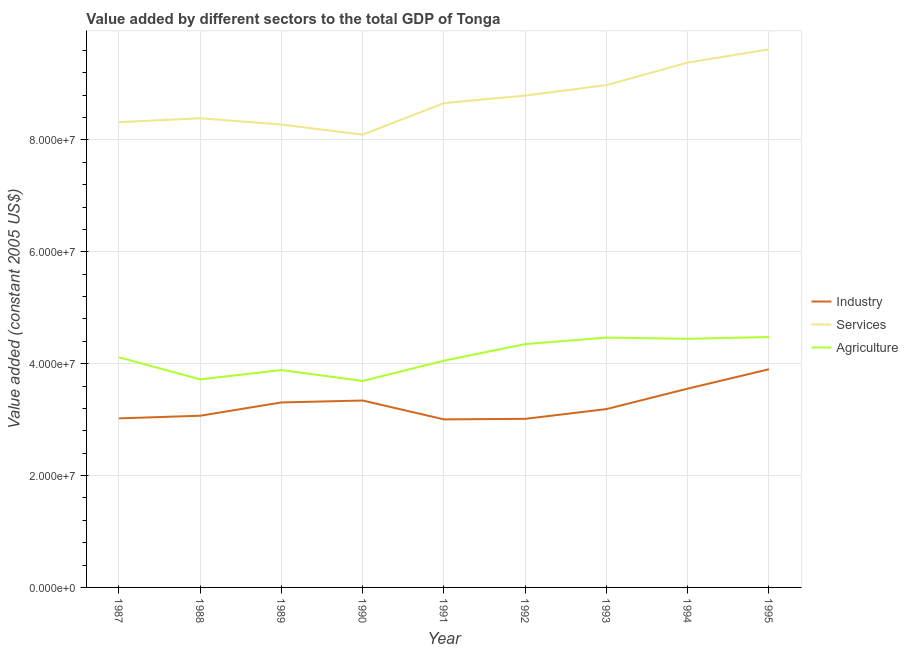What is the value added by industrial sector in 1991?
Offer a very short reply. 3.00e+07. Across all years, what is the maximum value added by agricultural sector?
Provide a short and direct response. 4.48e+07. Across all years, what is the minimum value added by services?
Keep it short and to the point. 8.09e+07. In which year was the value added by agricultural sector minimum?
Your response must be concise. 1990. What is the total value added by services in the graph?
Your answer should be compact. 7.85e+08. What is the difference between the value added by industrial sector in 1989 and that in 1991?
Ensure brevity in your answer.  3.03e+06. What is the difference between the value added by services in 1988 and the value added by agricultural sector in 1993?
Give a very brief answer. 3.92e+07. What is the average value added by agricultural sector per year?
Make the answer very short. 4.13e+07. In the year 1994, what is the difference between the value added by agricultural sector and value added by industrial sector?
Your answer should be very brief. 8.91e+06. In how many years, is the value added by agricultural sector greater than 80000000 US$?
Provide a short and direct response. 0. What is the ratio of the value added by services in 1988 to that in 1995?
Give a very brief answer. 0.87. Is the value added by industrial sector in 1990 less than that in 1992?
Your answer should be very brief. No. What is the difference between the highest and the second highest value added by agricultural sector?
Your answer should be compact. 1.02e+05. What is the difference between the highest and the lowest value added by services?
Ensure brevity in your answer.  1.53e+07. Is it the case that in every year, the sum of the value added by industrial sector and value added by services is greater than the value added by agricultural sector?
Provide a succinct answer. Yes. Does the value added by industrial sector monotonically increase over the years?
Give a very brief answer. No. Is the value added by services strictly less than the value added by agricultural sector over the years?
Keep it short and to the point. No. How many lines are there?
Your answer should be very brief. 3. How many years are there in the graph?
Provide a short and direct response. 9. Are the values on the major ticks of Y-axis written in scientific E-notation?
Give a very brief answer. Yes. How many legend labels are there?
Make the answer very short. 3. How are the legend labels stacked?
Keep it short and to the point. Vertical. What is the title of the graph?
Your response must be concise. Value added by different sectors to the total GDP of Tonga. What is the label or title of the Y-axis?
Offer a very short reply. Value added (constant 2005 US$). What is the Value added (constant 2005 US$) in Industry in 1987?
Your answer should be very brief. 3.02e+07. What is the Value added (constant 2005 US$) of Services in 1987?
Offer a very short reply. 8.32e+07. What is the Value added (constant 2005 US$) in Agriculture in 1987?
Give a very brief answer. 4.11e+07. What is the Value added (constant 2005 US$) in Industry in 1988?
Keep it short and to the point. 3.07e+07. What is the Value added (constant 2005 US$) of Services in 1988?
Your response must be concise. 8.39e+07. What is the Value added (constant 2005 US$) in Agriculture in 1988?
Provide a short and direct response. 3.72e+07. What is the Value added (constant 2005 US$) in Industry in 1989?
Offer a very short reply. 3.31e+07. What is the Value added (constant 2005 US$) of Services in 1989?
Make the answer very short. 8.28e+07. What is the Value added (constant 2005 US$) in Agriculture in 1989?
Offer a very short reply. 3.89e+07. What is the Value added (constant 2005 US$) of Industry in 1990?
Provide a short and direct response. 3.34e+07. What is the Value added (constant 2005 US$) in Services in 1990?
Make the answer very short. 8.09e+07. What is the Value added (constant 2005 US$) in Agriculture in 1990?
Your response must be concise. 3.69e+07. What is the Value added (constant 2005 US$) of Industry in 1991?
Provide a short and direct response. 3.00e+07. What is the Value added (constant 2005 US$) in Services in 1991?
Your answer should be compact. 8.66e+07. What is the Value added (constant 2005 US$) in Agriculture in 1991?
Offer a very short reply. 4.05e+07. What is the Value added (constant 2005 US$) in Industry in 1992?
Your response must be concise. 3.01e+07. What is the Value added (constant 2005 US$) in Services in 1992?
Offer a very short reply. 8.79e+07. What is the Value added (constant 2005 US$) in Agriculture in 1992?
Offer a very short reply. 4.35e+07. What is the Value added (constant 2005 US$) of Industry in 1993?
Your answer should be very brief. 3.19e+07. What is the Value added (constant 2005 US$) in Services in 1993?
Your response must be concise. 8.98e+07. What is the Value added (constant 2005 US$) in Agriculture in 1993?
Offer a very short reply. 4.47e+07. What is the Value added (constant 2005 US$) of Industry in 1994?
Ensure brevity in your answer.  3.55e+07. What is the Value added (constant 2005 US$) in Services in 1994?
Give a very brief answer. 9.38e+07. What is the Value added (constant 2005 US$) in Agriculture in 1994?
Keep it short and to the point. 4.44e+07. What is the Value added (constant 2005 US$) in Industry in 1995?
Keep it short and to the point. 3.90e+07. What is the Value added (constant 2005 US$) of Services in 1995?
Ensure brevity in your answer.  9.62e+07. What is the Value added (constant 2005 US$) in Agriculture in 1995?
Give a very brief answer. 4.48e+07. Across all years, what is the maximum Value added (constant 2005 US$) in Industry?
Your answer should be very brief. 3.90e+07. Across all years, what is the maximum Value added (constant 2005 US$) in Services?
Offer a very short reply. 9.62e+07. Across all years, what is the maximum Value added (constant 2005 US$) of Agriculture?
Make the answer very short. 4.48e+07. Across all years, what is the minimum Value added (constant 2005 US$) of Industry?
Keep it short and to the point. 3.00e+07. Across all years, what is the minimum Value added (constant 2005 US$) in Services?
Provide a short and direct response. 8.09e+07. Across all years, what is the minimum Value added (constant 2005 US$) of Agriculture?
Give a very brief answer. 3.69e+07. What is the total Value added (constant 2005 US$) in Industry in the graph?
Your answer should be very brief. 2.94e+08. What is the total Value added (constant 2005 US$) of Services in the graph?
Your response must be concise. 7.85e+08. What is the total Value added (constant 2005 US$) of Agriculture in the graph?
Offer a terse response. 3.72e+08. What is the difference between the Value added (constant 2005 US$) of Industry in 1987 and that in 1988?
Offer a very short reply. -4.72e+05. What is the difference between the Value added (constant 2005 US$) of Services in 1987 and that in 1988?
Offer a terse response. -6.96e+05. What is the difference between the Value added (constant 2005 US$) of Agriculture in 1987 and that in 1988?
Offer a very short reply. 3.95e+06. What is the difference between the Value added (constant 2005 US$) of Industry in 1987 and that in 1989?
Offer a terse response. -2.85e+06. What is the difference between the Value added (constant 2005 US$) in Services in 1987 and that in 1989?
Offer a very short reply. 4.27e+05. What is the difference between the Value added (constant 2005 US$) of Agriculture in 1987 and that in 1989?
Make the answer very short. 2.28e+06. What is the difference between the Value added (constant 2005 US$) of Industry in 1987 and that in 1990?
Your answer should be compact. -3.19e+06. What is the difference between the Value added (constant 2005 US$) in Services in 1987 and that in 1990?
Provide a succinct answer. 2.23e+06. What is the difference between the Value added (constant 2005 US$) of Agriculture in 1987 and that in 1990?
Your response must be concise. 4.24e+06. What is the difference between the Value added (constant 2005 US$) in Industry in 1987 and that in 1991?
Ensure brevity in your answer.  1.77e+05. What is the difference between the Value added (constant 2005 US$) in Services in 1987 and that in 1991?
Make the answer very short. -3.40e+06. What is the difference between the Value added (constant 2005 US$) in Agriculture in 1987 and that in 1991?
Offer a very short reply. 6.11e+05. What is the difference between the Value added (constant 2005 US$) of Industry in 1987 and that in 1992?
Your response must be concise. 8.38e+04. What is the difference between the Value added (constant 2005 US$) in Services in 1987 and that in 1992?
Offer a very short reply. -4.75e+06. What is the difference between the Value added (constant 2005 US$) of Agriculture in 1987 and that in 1992?
Provide a short and direct response. -2.36e+06. What is the difference between the Value added (constant 2005 US$) in Industry in 1987 and that in 1993?
Your response must be concise. -1.66e+06. What is the difference between the Value added (constant 2005 US$) of Services in 1987 and that in 1993?
Your answer should be compact. -6.63e+06. What is the difference between the Value added (constant 2005 US$) in Agriculture in 1987 and that in 1993?
Offer a terse response. -3.52e+06. What is the difference between the Value added (constant 2005 US$) of Industry in 1987 and that in 1994?
Your answer should be compact. -5.32e+06. What is the difference between the Value added (constant 2005 US$) of Services in 1987 and that in 1994?
Keep it short and to the point. -1.06e+07. What is the difference between the Value added (constant 2005 US$) in Agriculture in 1987 and that in 1994?
Make the answer very short. -3.30e+06. What is the difference between the Value added (constant 2005 US$) of Industry in 1987 and that in 1995?
Offer a very short reply. -8.78e+06. What is the difference between the Value added (constant 2005 US$) in Services in 1987 and that in 1995?
Make the answer very short. -1.30e+07. What is the difference between the Value added (constant 2005 US$) in Agriculture in 1987 and that in 1995?
Your answer should be compact. -3.62e+06. What is the difference between the Value added (constant 2005 US$) of Industry in 1988 and that in 1989?
Provide a succinct answer. -2.38e+06. What is the difference between the Value added (constant 2005 US$) of Services in 1988 and that in 1989?
Give a very brief answer. 1.12e+06. What is the difference between the Value added (constant 2005 US$) in Agriculture in 1988 and that in 1989?
Ensure brevity in your answer.  -1.67e+06. What is the difference between the Value added (constant 2005 US$) in Industry in 1988 and that in 1990?
Make the answer very short. -2.72e+06. What is the difference between the Value added (constant 2005 US$) of Services in 1988 and that in 1990?
Your answer should be very brief. 2.93e+06. What is the difference between the Value added (constant 2005 US$) in Agriculture in 1988 and that in 1990?
Make the answer very short. 2.86e+05. What is the difference between the Value added (constant 2005 US$) in Industry in 1988 and that in 1991?
Provide a succinct answer. 6.49e+05. What is the difference between the Value added (constant 2005 US$) of Services in 1988 and that in 1991?
Keep it short and to the point. -2.71e+06. What is the difference between the Value added (constant 2005 US$) in Agriculture in 1988 and that in 1991?
Ensure brevity in your answer.  -3.34e+06. What is the difference between the Value added (constant 2005 US$) in Industry in 1988 and that in 1992?
Give a very brief answer. 5.56e+05. What is the difference between the Value added (constant 2005 US$) of Services in 1988 and that in 1992?
Ensure brevity in your answer.  -4.06e+06. What is the difference between the Value added (constant 2005 US$) of Agriculture in 1988 and that in 1992?
Provide a short and direct response. -6.31e+06. What is the difference between the Value added (constant 2005 US$) in Industry in 1988 and that in 1993?
Ensure brevity in your answer.  -1.19e+06. What is the difference between the Value added (constant 2005 US$) of Services in 1988 and that in 1993?
Offer a terse response. -5.93e+06. What is the difference between the Value added (constant 2005 US$) of Agriculture in 1988 and that in 1993?
Provide a succinct answer. -7.47e+06. What is the difference between the Value added (constant 2005 US$) of Industry in 1988 and that in 1994?
Give a very brief answer. -4.85e+06. What is the difference between the Value added (constant 2005 US$) in Services in 1988 and that in 1994?
Give a very brief answer. -9.95e+06. What is the difference between the Value added (constant 2005 US$) in Agriculture in 1988 and that in 1994?
Your answer should be compact. -7.25e+06. What is the difference between the Value added (constant 2005 US$) of Industry in 1988 and that in 1995?
Ensure brevity in your answer.  -8.31e+06. What is the difference between the Value added (constant 2005 US$) of Services in 1988 and that in 1995?
Provide a short and direct response. -1.23e+07. What is the difference between the Value added (constant 2005 US$) of Agriculture in 1988 and that in 1995?
Your answer should be very brief. -7.57e+06. What is the difference between the Value added (constant 2005 US$) of Industry in 1989 and that in 1990?
Ensure brevity in your answer.  -3.42e+05. What is the difference between the Value added (constant 2005 US$) in Services in 1989 and that in 1990?
Your answer should be very brief. 1.81e+06. What is the difference between the Value added (constant 2005 US$) in Agriculture in 1989 and that in 1990?
Make the answer very short. 1.96e+06. What is the difference between the Value added (constant 2005 US$) of Industry in 1989 and that in 1991?
Offer a terse response. 3.03e+06. What is the difference between the Value added (constant 2005 US$) of Services in 1989 and that in 1991?
Ensure brevity in your answer.  -3.83e+06. What is the difference between the Value added (constant 2005 US$) in Agriculture in 1989 and that in 1991?
Make the answer very short. -1.67e+06. What is the difference between the Value added (constant 2005 US$) in Industry in 1989 and that in 1992?
Your answer should be very brief. 2.93e+06. What is the difference between the Value added (constant 2005 US$) of Services in 1989 and that in 1992?
Offer a terse response. -5.18e+06. What is the difference between the Value added (constant 2005 US$) in Agriculture in 1989 and that in 1992?
Offer a very short reply. -4.64e+06. What is the difference between the Value added (constant 2005 US$) in Industry in 1989 and that in 1993?
Provide a short and direct response. 1.19e+06. What is the difference between the Value added (constant 2005 US$) of Services in 1989 and that in 1993?
Offer a terse response. -7.05e+06. What is the difference between the Value added (constant 2005 US$) in Agriculture in 1989 and that in 1993?
Your answer should be very brief. -5.80e+06. What is the difference between the Value added (constant 2005 US$) of Industry in 1989 and that in 1994?
Offer a terse response. -2.47e+06. What is the difference between the Value added (constant 2005 US$) of Services in 1989 and that in 1994?
Provide a short and direct response. -1.11e+07. What is the difference between the Value added (constant 2005 US$) in Agriculture in 1989 and that in 1994?
Ensure brevity in your answer.  -5.58e+06. What is the difference between the Value added (constant 2005 US$) in Industry in 1989 and that in 1995?
Make the answer very short. -5.93e+06. What is the difference between the Value added (constant 2005 US$) in Services in 1989 and that in 1995?
Ensure brevity in your answer.  -1.34e+07. What is the difference between the Value added (constant 2005 US$) of Agriculture in 1989 and that in 1995?
Your answer should be very brief. -5.90e+06. What is the difference between the Value added (constant 2005 US$) in Industry in 1990 and that in 1991?
Ensure brevity in your answer.  3.37e+06. What is the difference between the Value added (constant 2005 US$) in Services in 1990 and that in 1991?
Offer a terse response. -5.64e+06. What is the difference between the Value added (constant 2005 US$) in Agriculture in 1990 and that in 1991?
Provide a succinct answer. -3.63e+06. What is the difference between the Value added (constant 2005 US$) of Industry in 1990 and that in 1992?
Keep it short and to the point. 3.28e+06. What is the difference between the Value added (constant 2005 US$) in Services in 1990 and that in 1992?
Offer a very short reply. -6.99e+06. What is the difference between the Value added (constant 2005 US$) of Agriculture in 1990 and that in 1992?
Give a very brief answer. -6.60e+06. What is the difference between the Value added (constant 2005 US$) of Industry in 1990 and that in 1993?
Your response must be concise. 1.53e+06. What is the difference between the Value added (constant 2005 US$) of Services in 1990 and that in 1993?
Keep it short and to the point. -8.86e+06. What is the difference between the Value added (constant 2005 US$) in Agriculture in 1990 and that in 1993?
Your answer should be compact. -7.76e+06. What is the difference between the Value added (constant 2005 US$) of Industry in 1990 and that in 1994?
Provide a succinct answer. -2.13e+06. What is the difference between the Value added (constant 2005 US$) of Services in 1990 and that in 1994?
Ensure brevity in your answer.  -1.29e+07. What is the difference between the Value added (constant 2005 US$) of Agriculture in 1990 and that in 1994?
Provide a succinct answer. -7.54e+06. What is the difference between the Value added (constant 2005 US$) of Industry in 1990 and that in 1995?
Your answer should be very brief. -5.59e+06. What is the difference between the Value added (constant 2005 US$) of Services in 1990 and that in 1995?
Keep it short and to the point. -1.53e+07. What is the difference between the Value added (constant 2005 US$) of Agriculture in 1990 and that in 1995?
Offer a terse response. -7.86e+06. What is the difference between the Value added (constant 2005 US$) of Industry in 1991 and that in 1992?
Your answer should be compact. -9.31e+04. What is the difference between the Value added (constant 2005 US$) of Services in 1991 and that in 1992?
Your answer should be very brief. -1.35e+06. What is the difference between the Value added (constant 2005 US$) in Agriculture in 1991 and that in 1992?
Your answer should be very brief. -2.97e+06. What is the difference between the Value added (constant 2005 US$) of Industry in 1991 and that in 1993?
Your answer should be compact. -1.84e+06. What is the difference between the Value added (constant 2005 US$) in Services in 1991 and that in 1993?
Provide a succinct answer. -3.23e+06. What is the difference between the Value added (constant 2005 US$) of Agriculture in 1991 and that in 1993?
Offer a terse response. -4.13e+06. What is the difference between the Value added (constant 2005 US$) of Industry in 1991 and that in 1994?
Make the answer very short. -5.50e+06. What is the difference between the Value added (constant 2005 US$) in Services in 1991 and that in 1994?
Ensure brevity in your answer.  -7.24e+06. What is the difference between the Value added (constant 2005 US$) of Agriculture in 1991 and that in 1994?
Your answer should be very brief. -3.91e+06. What is the difference between the Value added (constant 2005 US$) of Industry in 1991 and that in 1995?
Offer a terse response. -8.96e+06. What is the difference between the Value added (constant 2005 US$) in Services in 1991 and that in 1995?
Give a very brief answer. -9.62e+06. What is the difference between the Value added (constant 2005 US$) of Agriculture in 1991 and that in 1995?
Ensure brevity in your answer.  -4.23e+06. What is the difference between the Value added (constant 2005 US$) of Industry in 1992 and that in 1993?
Offer a very short reply. -1.74e+06. What is the difference between the Value added (constant 2005 US$) in Services in 1992 and that in 1993?
Give a very brief answer. -1.87e+06. What is the difference between the Value added (constant 2005 US$) of Agriculture in 1992 and that in 1993?
Provide a succinct answer. -1.16e+06. What is the difference between the Value added (constant 2005 US$) in Industry in 1992 and that in 1994?
Your answer should be compact. -5.40e+06. What is the difference between the Value added (constant 2005 US$) in Services in 1992 and that in 1994?
Your response must be concise. -5.89e+06. What is the difference between the Value added (constant 2005 US$) of Agriculture in 1992 and that in 1994?
Ensure brevity in your answer.  -9.43e+05. What is the difference between the Value added (constant 2005 US$) in Industry in 1992 and that in 1995?
Your response must be concise. -8.86e+06. What is the difference between the Value added (constant 2005 US$) in Services in 1992 and that in 1995?
Provide a succinct answer. -8.27e+06. What is the difference between the Value added (constant 2005 US$) in Agriculture in 1992 and that in 1995?
Provide a short and direct response. -1.26e+06. What is the difference between the Value added (constant 2005 US$) of Industry in 1993 and that in 1994?
Make the answer very short. -3.66e+06. What is the difference between the Value added (constant 2005 US$) in Services in 1993 and that in 1994?
Your response must be concise. -4.02e+06. What is the difference between the Value added (constant 2005 US$) in Agriculture in 1993 and that in 1994?
Offer a very short reply. 2.17e+05. What is the difference between the Value added (constant 2005 US$) in Industry in 1993 and that in 1995?
Your answer should be compact. -7.12e+06. What is the difference between the Value added (constant 2005 US$) in Services in 1993 and that in 1995?
Give a very brief answer. -6.39e+06. What is the difference between the Value added (constant 2005 US$) of Agriculture in 1993 and that in 1995?
Your answer should be very brief. -1.02e+05. What is the difference between the Value added (constant 2005 US$) in Industry in 1994 and that in 1995?
Offer a terse response. -3.46e+06. What is the difference between the Value added (constant 2005 US$) of Services in 1994 and that in 1995?
Keep it short and to the point. -2.38e+06. What is the difference between the Value added (constant 2005 US$) in Agriculture in 1994 and that in 1995?
Give a very brief answer. -3.19e+05. What is the difference between the Value added (constant 2005 US$) of Industry in 1987 and the Value added (constant 2005 US$) of Services in 1988?
Make the answer very short. -5.37e+07. What is the difference between the Value added (constant 2005 US$) in Industry in 1987 and the Value added (constant 2005 US$) in Agriculture in 1988?
Offer a very short reply. -6.97e+06. What is the difference between the Value added (constant 2005 US$) of Services in 1987 and the Value added (constant 2005 US$) of Agriculture in 1988?
Provide a succinct answer. 4.60e+07. What is the difference between the Value added (constant 2005 US$) in Industry in 1987 and the Value added (constant 2005 US$) in Services in 1989?
Your answer should be very brief. -5.25e+07. What is the difference between the Value added (constant 2005 US$) of Industry in 1987 and the Value added (constant 2005 US$) of Agriculture in 1989?
Keep it short and to the point. -8.64e+06. What is the difference between the Value added (constant 2005 US$) of Services in 1987 and the Value added (constant 2005 US$) of Agriculture in 1989?
Provide a succinct answer. 4.43e+07. What is the difference between the Value added (constant 2005 US$) in Industry in 1987 and the Value added (constant 2005 US$) in Services in 1990?
Your response must be concise. -5.07e+07. What is the difference between the Value added (constant 2005 US$) of Industry in 1987 and the Value added (constant 2005 US$) of Agriculture in 1990?
Offer a very short reply. -6.69e+06. What is the difference between the Value added (constant 2005 US$) in Services in 1987 and the Value added (constant 2005 US$) in Agriculture in 1990?
Offer a very short reply. 4.63e+07. What is the difference between the Value added (constant 2005 US$) in Industry in 1987 and the Value added (constant 2005 US$) in Services in 1991?
Ensure brevity in your answer.  -5.64e+07. What is the difference between the Value added (constant 2005 US$) of Industry in 1987 and the Value added (constant 2005 US$) of Agriculture in 1991?
Give a very brief answer. -1.03e+07. What is the difference between the Value added (constant 2005 US$) of Services in 1987 and the Value added (constant 2005 US$) of Agriculture in 1991?
Give a very brief answer. 4.26e+07. What is the difference between the Value added (constant 2005 US$) of Industry in 1987 and the Value added (constant 2005 US$) of Services in 1992?
Give a very brief answer. -5.77e+07. What is the difference between the Value added (constant 2005 US$) in Industry in 1987 and the Value added (constant 2005 US$) in Agriculture in 1992?
Your answer should be very brief. -1.33e+07. What is the difference between the Value added (constant 2005 US$) of Services in 1987 and the Value added (constant 2005 US$) of Agriculture in 1992?
Ensure brevity in your answer.  3.97e+07. What is the difference between the Value added (constant 2005 US$) of Industry in 1987 and the Value added (constant 2005 US$) of Services in 1993?
Ensure brevity in your answer.  -5.96e+07. What is the difference between the Value added (constant 2005 US$) in Industry in 1987 and the Value added (constant 2005 US$) in Agriculture in 1993?
Ensure brevity in your answer.  -1.44e+07. What is the difference between the Value added (constant 2005 US$) in Services in 1987 and the Value added (constant 2005 US$) in Agriculture in 1993?
Your answer should be compact. 3.85e+07. What is the difference between the Value added (constant 2005 US$) in Industry in 1987 and the Value added (constant 2005 US$) in Services in 1994?
Provide a succinct answer. -6.36e+07. What is the difference between the Value added (constant 2005 US$) of Industry in 1987 and the Value added (constant 2005 US$) of Agriculture in 1994?
Keep it short and to the point. -1.42e+07. What is the difference between the Value added (constant 2005 US$) of Services in 1987 and the Value added (constant 2005 US$) of Agriculture in 1994?
Your response must be concise. 3.87e+07. What is the difference between the Value added (constant 2005 US$) of Industry in 1987 and the Value added (constant 2005 US$) of Services in 1995?
Ensure brevity in your answer.  -6.60e+07. What is the difference between the Value added (constant 2005 US$) in Industry in 1987 and the Value added (constant 2005 US$) in Agriculture in 1995?
Your response must be concise. -1.45e+07. What is the difference between the Value added (constant 2005 US$) in Services in 1987 and the Value added (constant 2005 US$) in Agriculture in 1995?
Your answer should be very brief. 3.84e+07. What is the difference between the Value added (constant 2005 US$) of Industry in 1988 and the Value added (constant 2005 US$) of Services in 1989?
Offer a very short reply. -5.21e+07. What is the difference between the Value added (constant 2005 US$) in Industry in 1988 and the Value added (constant 2005 US$) in Agriculture in 1989?
Provide a succinct answer. -8.17e+06. What is the difference between the Value added (constant 2005 US$) in Services in 1988 and the Value added (constant 2005 US$) in Agriculture in 1989?
Your answer should be compact. 4.50e+07. What is the difference between the Value added (constant 2005 US$) in Industry in 1988 and the Value added (constant 2005 US$) in Services in 1990?
Provide a succinct answer. -5.03e+07. What is the difference between the Value added (constant 2005 US$) in Industry in 1988 and the Value added (constant 2005 US$) in Agriculture in 1990?
Keep it short and to the point. -6.21e+06. What is the difference between the Value added (constant 2005 US$) in Services in 1988 and the Value added (constant 2005 US$) in Agriculture in 1990?
Offer a very short reply. 4.70e+07. What is the difference between the Value added (constant 2005 US$) of Industry in 1988 and the Value added (constant 2005 US$) of Services in 1991?
Your answer should be very brief. -5.59e+07. What is the difference between the Value added (constant 2005 US$) of Industry in 1988 and the Value added (constant 2005 US$) of Agriculture in 1991?
Ensure brevity in your answer.  -9.84e+06. What is the difference between the Value added (constant 2005 US$) of Services in 1988 and the Value added (constant 2005 US$) of Agriculture in 1991?
Your answer should be very brief. 4.33e+07. What is the difference between the Value added (constant 2005 US$) of Industry in 1988 and the Value added (constant 2005 US$) of Services in 1992?
Provide a succinct answer. -5.72e+07. What is the difference between the Value added (constant 2005 US$) in Industry in 1988 and the Value added (constant 2005 US$) in Agriculture in 1992?
Give a very brief answer. -1.28e+07. What is the difference between the Value added (constant 2005 US$) in Services in 1988 and the Value added (constant 2005 US$) in Agriculture in 1992?
Make the answer very short. 4.04e+07. What is the difference between the Value added (constant 2005 US$) of Industry in 1988 and the Value added (constant 2005 US$) of Services in 1993?
Offer a terse response. -5.91e+07. What is the difference between the Value added (constant 2005 US$) in Industry in 1988 and the Value added (constant 2005 US$) in Agriculture in 1993?
Give a very brief answer. -1.40e+07. What is the difference between the Value added (constant 2005 US$) in Services in 1988 and the Value added (constant 2005 US$) in Agriculture in 1993?
Offer a very short reply. 3.92e+07. What is the difference between the Value added (constant 2005 US$) in Industry in 1988 and the Value added (constant 2005 US$) in Services in 1994?
Keep it short and to the point. -6.31e+07. What is the difference between the Value added (constant 2005 US$) of Industry in 1988 and the Value added (constant 2005 US$) of Agriculture in 1994?
Your answer should be very brief. -1.38e+07. What is the difference between the Value added (constant 2005 US$) of Services in 1988 and the Value added (constant 2005 US$) of Agriculture in 1994?
Provide a short and direct response. 3.94e+07. What is the difference between the Value added (constant 2005 US$) in Industry in 1988 and the Value added (constant 2005 US$) in Services in 1995?
Your response must be concise. -6.55e+07. What is the difference between the Value added (constant 2005 US$) in Industry in 1988 and the Value added (constant 2005 US$) in Agriculture in 1995?
Your answer should be very brief. -1.41e+07. What is the difference between the Value added (constant 2005 US$) in Services in 1988 and the Value added (constant 2005 US$) in Agriculture in 1995?
Provide a short and direct response. 3.91e+07. What is the difference between the Value added (constant 2005 US$) of Industry in 1989 and the Value added (constant 2005 US$) of Services in 1990?
Give a very brief answer. -4.79e+07. What is the difference between the Value added (constant 2005 US$) in Industry in 1989 and the Value added (constant 2005 US$) in Agriculture in 1990?
Offer a very short reply. -3.84e+06. What is the difference between the Value added (constant 2005 US$) of Services in 1989 and the Value added (constant 2005 US$) of Agriculture in 1990?
Offer a terse response. 4.58e+07. What is the difference between the Value added (constant 2005 US$) of Industry in 1989 and the Value added (constant 2005 US$) of Services in 1991?
Ensure brevity in your answer.  -5.35e+07. What is the difference between the Value added (constant 2005 US$) in Industry in 1989 and the Value added (constant 2005 US$) in Agriculture in 1991?
Provide a short and direct response. -7.46e+06. What is the difference between the Value added (constant 2005 US$) in Services in 1989 and the Value added (constant 2005 US$) in Agriculture in 1991?
Ensure brevity in your answer.  4.22e+07. What is the difference between the Value added (constant 2005 US$) in Industry in 1989 and the Value added (constant 2005 US$) in Services in 1992?
Keep it short and to the point. -5.49e+07. What is the difference between the Value added (constant 2005 US$) in Industry in 1989 and the Value added (constant 2005 US$) in Agriculture in 1992?
Provide a short and direct response. -1.04e+07. What is the difference between the Value added (constant 2005 US$) of Services in 1989 and the Value added (constant 2005 US$) of Agriculture in 1992?
Make the answer very short. 3.92e+07. What is the difference between the Value added (constant 2005 US$) of Industry in 1989 and the Value added (constant 2005 US$) of Services in 1993?
Provide a short and direct response. -5.67e+07. What is the difference between the Value added (constant 2005 US$) of Industry in 1989 and the Value added (constant 2005 US$) of Agriculture in 1993?
Make the answer very short. -1.16e+07. What is the difference between the Value added (constant 2005 US$) in Services in 1989 and the Value added (constant 2005 US$) in Agriculture in 1993?
Provide a succinct answer. 3.81e+07. What is the difference between the Value added (constant 2005 US$) of Industry in 1989 and the Value added (constant 2005 US$) of Services in 1994?
Your response must be concise. -6.08e+07. What is the difference between the Value added (constant 2005 US$) of Industry in 1989 and the Value added (constant 2005 US$) of Agriculture in 1994?
Keep it short and to the point. -1.14e+07. What is the difference between the Value added (constant 2005 US$) in Services in 1989 and the Value added (constant 2005 US$) in Agriculture in 1994?
Your answer should be very brief. 3.83e+07. What is the difference between the Value added (constant 2005 US$) in Industry in 1989 and the Value added (constant 2005 US$) in Services in 1995?
Provide a short and direct response. -6.31e+07. What is the difference between the Value added (constant 2005 US$) of Industry in 1989 and the Value added (constant 2005 US$) of Agriculture in 1995?
Offer a very short reply. -1.17e+07. What is the difference between the Value added (constant 2005 US$) in Services in 1989 and the Value added (constant 2005 US$) in Agriculture in 1995?
Ensure brevity in your answer.  3.80e+07. What is the difference between the Value added (constant 2005 US$) of Industry in 1990 and the Value added (constant 2005 US$) of Services in 1991?
Keep it short and to the point. -5.32e+07. What is the difference between the Value added (constant 2005 US$) of Industry in 1990 and the Value added (constant 2005 US$) of Agriculture in 1991?
Offer a very short reply. -7.12e+06. What is the difference between the Value added (constant 2005 US$) of Services in 1990 and the Value added (constant 2005 US$) of Agriculture in 1991?
Offer a terse response. 4.04e+07. What is the difference between the Value added (constant 2005 US$) in Industry in 1990 and the Value added (constant 2005 US$) in Services in 1992?
Your answer should be compact. -5.45e+07. What is the difference between the Value added (constant 2005 US$) of Industry in 1990 and the Value added (constant 2005 US$) of Agriculture in 1992?
Make the answer very short. -1.01e+07. What is the difference between the Value added (constant 2005 US$) in Services in 1990 and the Value added (constant 2005 US$) in Agriculture in 1992?
Your answer should be compact. 3.74e+07. What is the difference between the Value added (constant 2005 US$) in Industry in 1990 and the Value added (constant 2005 US$) in Services in 1993?
Ensure brevity in your answer.  -5.64e+07. What is the difference between the Value added (constant 2005 US$) in Industry in 1990 and the Value added (constant 2005 US$) in Agriculture in 1993?
Give a very brief answer. -1.13e+07. What is the difference between the Value added (constant 2005 US$) in Services in 1990 and the Value added (constant 2005 US$) in Agriculture in 1993?
Your answer should be compact. 3.63e+07. What is the difference between the Value added (constant 2005 US$) in Industry in 1990 and the Value added (constant 2005 US$) in Services in 1994?
Your response must be concise. -6.04e+07. What is the difference between the Value added (constant 2005 US$) in Industry in 1990 and the Value added (constant 2005 US$) in Agriculture in 1994?
Your answer should be very brief. -1.10e+07. What is the difference between the Value added (constant 2005 US$) in Services in 1990 and the Value added (constant 2005 US$) in Agriculture in 1994?
Offer a very short reply. 3.65e+07. What is the difference between the Value added (constant 2005 US$) in Industry in 1990 and the Value added (constant 2005 US$) in Services in 1995?
Offer a terse response. -6.28e+07. What is the difference between the Value added (constant 2005 US$) in Industry in 1990 and the Value added (constant 2005 US$) in Agriculture in 1995?
Give a very brief answer. -1.14e+07. What is the difference between the Value added (constant 2005 US$) of Services in 1990 and the Value added (constant 2005 US$) of Agriculture in 1995?
Your answer should be compact. 3.62e+07. What is the difference between the Value added (constant 2005 US$) of Industry in 1991 and the Value added (constant 2005 US$) of Services in 1992?
Your response must be concise. -5.79e+07. What is the difference between the Value added (constant 2005 US$) of Industry in 1991 and the Value added (constant 2005 US$) of Agriculture in 1992?
Your response must be concise. -1.35e+07. What is the difference between the Value added (constant 2005 US$) in Services in 1991 and the Value added (constant 2005 US$) in Agriculture in 1992?
Keep it short and to the point. 4.31e+07. What is the difference between the Value added (constant 2005 US$) in Industry in 1991 and the Value added (constant 2005 US$) in Services in 1993?
Ensure brevity in your answer.  -5.98e+07. What is the difference between the Value added (constant 2005 US$) of Industry in 1991 and the Value added (constant 2005 US$) of Agriculture in 1993?
Your answer should be compact. -1.46e+07. What is the difference between the Value added (constant 2005 US$) in Services in 1991 and the Value added (constant 2005 US$) in Agriculture in 1993?
Offer a very short reply. 4.19e+07. What is the difference between the Value added (constant 2005 US$) of Industry in 1991 and the Value added (constant 2005 US$) of Services in 1994?
Your response must be concise. -6.38e+07. What is the difference between the Value added (constant 2005 US$) in Industry in 1991 and the Value added (constant 2005 US$) in Agriculture in 1994?
Provide a succinct answer. -1.44e+07. What is the difference between the Value added (constant 2005 US$) in Services in 1991 and the Value added (constant 2005 US$) in Agriculture in 1994?
Ensure brevity in your answer.  4.21e+07. What is the difference between the Value added (constant 2005 US$) of Industry in 1991 and the Value added (constant 2005 US$) of Services in 1995?
Give a very brief answer. -6.62e+07. What is the difference between the Value added (constant 2005 US$) of Industry in 1991 and the Value added (constant 2005 US$) of Agriculture in 1995?
Make the answer very short. -1.47e+07. What is the difference between the Value added (constant 2005 US$) in Services in 1991 and the Value added (constant 2005 US$) in Agriculture in 1995?
Offer a very short reply. 4.18e+07. What is the difference between the Value added (constant 2005 US$) of Industry in 1992 and the Value added (constant 2005 US$) of Services in 1993?
Make the answer very short. -5.97e+07. What is the difference between the Value added (constant 2005 US$) in Industry in 1992 and the Value added (constant 2005 US$) in Agriculture in 1993?
Ensure brevity in your answer.  -1.45e+07. What is the difference between the Value added (constant 2005 US$) of Services in 1992 and the Value added (constant 2005 US$) of Agriculture in 1993?
Offer a very short reply. 4.33e+07. What is the difference between the Value added (constant 2005 US$) in Industry in 1992 and the Value added (constant 2005 US$) in Services in 1994?
Offer a very short reply. -6.37e+07. What is the difference between the Value added (constant 2005 US$) of Industry in 1992 and the Value added (constant 2005 US$) of Agriculture in 1994?
Your answer should be very brief. -1.43e+07. What is the difference between the Value added (constant 2005 US$) of Services in 1992 and the Value added (constant 2005 US$) of Agriculture in 1994?
Offer a very short reply. 4.35e+07. What is the difference between the Value added (constant 2005 US$) of Industry in 1992 and the Value added (constant 2005 US$) of Services in 1995?
Give a very brief answer. -6.61e+07. What is the difference between the Value added (constant 2005 US$) in Industry in 1992 and the Value added (constant 2005 US$) in Agriculture in 1995?
Provide a short and direct response. -1.46e+07. What is the difference between the Value added (constant 2005 US$) in Services in 1992 and the Value added (constant 2005 US$) in Agriculture in 1995?
Give a very brief answer. 4.32e+07. What is the difference between the Value added (constant 2005 US$) in Industry in 1993 and the Value added (constant 2005 US$) in Services in 1994?
Offer a very short reply. -6.19e+07. What is the difference between the Value added (constant 2005 US$) in Industry in 1993 and the Value added (constant 2005 US$) in Agriculture in 1994?
Your answer should be compact. -1.26e+07. What is the difference between the Value added (constant 2005 US$) in Services in 1993 and the Value added (constant 2005 US$) in Agriculture in 1994?
Make the answer very short. 4.54e+07. What is the difference between the Value added (constant 2005 US$) of Industry in 1993 and the Value added (constant 2005 US$) of Services in 1995?
Offer a terse response. -6.43e+07. What is the difference between the Value added (constant 2005 US$) of Industry in 1993 and the Value added (constant 2005 US$) of Agriculture in 1995?
Keep it short and to the point. -1.29e+07. What is the difference between the Value added (constant 2005 US$) in Services in 1993 and the Value added (constant 2005 US$) in Agriculture in 1995?
Offer a very short reply. 4.50e+07. What is the difference between the Value added (constant 2005 US$) in Industry in 1994 and the Value added (constant 2005 US$) in Services in 1995?
Offer a terse response. -6.07e+07. What is the difference between the Value added (constant 2005 US$) of Industry in 1994 and the Value added (constant 2005 US$) of Agriculture in 1995?
Provide a succinct answer. -9.23e+06. What is the difference between the Value added (constant 2005 US$) in Services in 1994 and the Value added (constant 2005 US$) in Agriculture in 1995?
Give a very brief answer. 4.91e+07. What is the average Value added (constant 2005 US$) of Industry per year?
Ensure brevity in your answer.  3.27e+07. What is the average Value added (constant 2005 US$) of Services per year?
Provide a short and direct response. 8.72e+07. What is the average Value added (constant 2005 US$) in Agriculture per year?
Ensure brevity in your answer.  4.13e+07. In the year 1987, what is the difference between the Value added (constant 2005 US$) of Industry and Value added (constant 2005 US$) of Services?
Give a very brief answer. -5.30e+07. In the year 1987, what is the difference between the Value added (constant 2005 US$) in Industry and Value added (constant 2005 US$) in Agriculture?
Your answer should be very brief. -1.09e+07. In the year 1987, what is the difference between the Value added (constant 2005 US$) in Services and Value added (constant 2005 US$) in Agriculture?
Ensure brevity in your answer.  4.20e+07. In the year 1988, what is the difference between the Value added (constant 2005 US$) of Industry and Value added (constant 2005 US$) of Services?
Provide a succinct answer. -5.32e+07. In the year 1988, what is the difference between the Value added (constant 2005 US$) of Industry and Value added (constant 2005 US$) of Agriculture?
Give a very brief answer. -6.50e+06. In the year 1988, what is the difference between the Value added (constant 2005 US$) of Services and Value added (constant 2005 US$) of Agriculture?
Offer a very short reply. 4.67e+07. In the year 1989, what is the difference between the Value added (constant 2005 US$) of Industry and Value added (constant 2005 US$) of Services?
Provide a succinct answer. -4.97e+07. In the year 1989, what is the difference between the Value added (constant 2005 US$) of Industry and Value added (constant 2005 US$) of Agriculture?
Make the answer very short. -5.79e+06. In the year 1989, what is the difference between the Value added (constant 2005 US$) of Services and Value added (constant 2005 US$) of Agriculture?
Provide a succinct answer. 4.39e+07. In the year 1990, what is the difference between the Value added (constant 2005 US$) in Industry and Value added (constant 2005 US$) in Services?
Ensure brevity in your answer.  -4.75e+07. In the year 1990, what is the difference between the Value added (constant 2005 US$) in Industry and Value added (constant 2005 US$) in Agriculture?
Your response must be concise. -3.49e+06. In the year 1990, what is the difference between the Value added (constant 2005 US$) of Services and Value added (constant 2005 US$) of Agriculture?
Ensure brevity in your answer.  4.40e+07. In the year 1991, what is the difference between the Value added (constant 2005 US$) in Industry and Value added (constant 2005 US$) in Services?
Your answer should be very brief. -5.65e+07. In the year 1991, what is the difference between the Value added (constant 2005 US$) in Industry and Value added (constant 2005 US$) in Agriculture?
Provide a short and direct response. -1.05e+07. In the year 1991, what is the difference between the Value added (constant 2005 US$) in Services and Value added (constant 2005 US$) in Agriculture?
Offer a very short reply. 4.60e+07. In the year 1992, what is the difference between the Value added (constant 2005 US$) of Industry and Value added (constant 2005 US$) of Services?
Your answer should be very brief. -5.78e+07. In the year 1992, what is the difference between the Value added (constant 2005 US$) in Industry and Value added (constant 2005 US$) in Agriculture?
Provide a succinct answer. -1.34e+07. In the year 1992, what is the difference between the Value added (constant 2005 US$) of Services and Value added (constant 2005 US$) of Agriculture?
Make the answer very short. 4.44e+07. In the year 1993, what is the difference between the Value added (constant 2005 US$) of Industry and Value added (constant 2005 US$) of Services?
Keep it short and to the point. -5.79e+07. In the year 1993, what is the difference between the Value added (constant 2005 US$) in Industry and Value added (constant 2005 US$) in Agriculture?
Your answer should be very brief. -1.28e+07. In the year 1993, what is the difference between the Value added (constant 2005 US$) of Services and Value added (constant 2005 US$) of Agriculture?
Provide a succinct answer. 4.51e+07. In the year 1994, what is the difference between the Value added (constant 2005 US$) in Industry and Value added (constant 2005 US$) in Services?
Make the answer very short. -5.83e+07. In the year 1994, what is the difference between the Value added (constant 2005 US$) of Industry and Value added (constant 2005 US$) of Agriculture?
Keep it short and to the point. -8.91e+06. In the year 1994, what is the difference between the Value added (constant 2005 US$) of Services and Value added (constant 2005 US$) of Agriculture?
Offer a terse response. 4.94e+07. In the year 1995, what is the difference between the Value added (constant 2005 US$) in Industry and Value added (constant 2005 US$) in Services?
Keep it short and to the point. -5.72e+07. In the year 1995, what is the difference between the Value added (constant 2005 US$) in Industry and Value added (constant 2005 US$) in Agriculture?
Offer a very short reply. -5.77e+06. In the year 1995, what is the difference between the Value added (constant 2005 US$) in Services and Value added (constant 2005 US$) in Agriculture?
Keep it short and to the point. 5.14e+07. What is the ratio of the Value added (constant 2005 US$) of Industry in 1987 to that in 1988?
Make the answer very short. 0.98. What is the ratio of the Value added (constant 2005 US$) in Agriculture in 1987 to that in 1988?
Give a very brief answer. 1.11. What is the ratio of the Value added (constant 2005 US$) in Industry in 1987 to that in 1989?
Provide a succinct answer. 0.91. What is the ratio of the Value added (constant 2005 US$) of Agriculture in 1987 to that in 1989?
Offer a terse response. 1.06. What is the ratio of the Value added (constant 2005 US$) in Industry in 1987 to that in 1990?
Ensure brevity in your answer.  0.9. What is the ratio of the Value added (constant 2005 US$) of Services in 1987 to that in 1990?
Provide a short and direct response. 1.03. What is the ratio of the Value added (constant 2005 US$) in Agriculture in 1987 to that in 1990?
Offer a very short reply. 1.11. What is the ratio of the Value added (constant 2005 US$) in Industry in 1987 to that in 1991?
Offer a terse response. 1.01. What is the ratio of the Value added (constant 2005 US$) of Services in 1987 to that in 1991?
Give a very brief answer. 0.96. What is the ratio of the Value added (constant 2005 US$) in Agriculture in 1987 to that in 1991?
Provide a succinct answer. 1.02. What is the ratio of the Value added (constant 2005 US$) of Industry in 1987 to that in 1992?
Give a very brief answer. 1. What is the ratio of the Value added (constant 2005 US$) of Services in 1987 to that in 1992?
Provide a short and direct response. 0.95. What is the ratio of the Value added (constant 2005 US$) of Agriculture in 1987 to that in 1992?
Keep it short and to the point. 0.95. What is the ratio of the Value added (constant 2005 US$) of Industry in 1987 to that in 1993?
Ensure brevity in your answer.  0.95. What is the ratio of the Value added (constant 2005 US$) of Services in 1987 to that in 1993?
Provide a short and direct response. 0.93. What is the ratio of the Value added (constant 2005 US$) in Agriculture in 1987 to that in 1993?
Offer a very short reply. 0.92. What is the ratio of the Value added (constant 2005 US$) in Industry in 1987 to that in 1994?
Your response must be concise. 0.85. What is the ratio of the Value added (constant 2005 US$) in Services in 1987 to that in 1994?
Provide a succinct answer. 0.89. What is the ratio of the Value added (constant 2005 US$) in Agriculture in 1987 to that in 1994?
Make the answer very short. 0.93. What is the ratio of the Value added (constant 2005 US$) of Industry in 1987 to that in 1995?
Keep it short and to the point. 0.77. What is the ratio of the Value added (constant 2005 US$) of Services in 1987 to that in 1995?
Your answer should be very brief. 0.86. What is the ratio of the Value added (constant 2005 US$) of Agriculture in 1987 to that in 1995?
Offer a very short reply. 0.92. What is the ratio of the Value added (constant 2005 US$) in Industry in 1988 to that in 1989?
Your answer should be compact. 0.93. What is the ratio of the Value added (constant 2005 US$) in Services in 1988 to that in 1989?
Ensure brevity in your answer.  1.01. What is the ratio of the Value added (constant 2005 US$) in Industry in 1988 to that in 1990?
Provide a succinct answer. 0.92. What is the ratio of the Value added (constant 2005 US$) in Services in 1988 to that in 1990?
Provide a succinct answer. 1.04. What is the ratio of the Value added (constant 2005 US$) in Agriculture in 1988 to that in 1990?
Provide a short and direct response. 1.01. What is the ratio of the Value added (constant 2005 US$) in Industry in 1988 to that in 1991?
Provide a succinct answer. 1.02. What is the ratio of the Value added (constant 2005 US$) in Services in 1988 to that in 1991?
Ensure brevity in your answer.  0.97. What is the ratio of the Value added (constant 2005 US$) in Agriculture in 1988 to that in 1991?
Give a very brief answer. 0.92. What is the ratio of the Value added (constant 2005 US$) in Industry in 1988 to that in 1992?
Your answer should be compact. 1.02. What is the ratio of the Value added (constant 2005 US$) in Services in 1988 to that in 1992?
Your response must be concise. 0.95. What is the ratio of the Value added (constant 2005 US$) of Agriculture in 1988 to that in 1992?
Your response must be concise. 0.85. What is the ratio of the Value added (constant 2005 US$) of Industry in 1988 to that in 1993?
Your response must be concise. 0.96. What is the ratio of the Value added (constant 2005 US$) of Services in 1988 to that in 1993?
Provide a short and direct response. 0.93. What is the ratio of the Value added (constant 2005 US$) of Agriculture in 1988 to that in 1993?
Offer a terse response. 0.83. What is the ratio of the Value added (constant 2005 US$) of Industry in 1988 to that in 1994?
Provide a short and direct response. 0.86. What is the ratio of the Value added (constant 2005 US$) in Services in 1988 to that in 1994?
Your response must be concise. 0.89. What is the ratio of the Value added (constant 2005 US$) in Agriculture in 1988 to that in 1994?
Keep it short and to the point. 0.84. What is the ratio of the Value added (constant 2005 US$) in Industry in 1988 to that in 1995?
Your response must be concise. 0.79. What is the ratio of the Value added (constant 2005 US$) in Services in 1988 to that in 1995?
Offer a very short reply. 0.87. What is the ratio of the Value added (constant 2005 US$) of Agriculture in 1988 to that in 1995?
Make the answer very short. 0.83. What is the ratio of the Value added (constant 2005 US$) of Services in 1989 to that in 1990?
Offer a very short reply. 1.02. What is the ratio of the Value added (constant 2005 US$) in Agriculture in 1989 to that in 1990?
Your answer should be very brief. 1.05. What is the ratio of the Value added (constant 2005 US$) of Industry in 1989 to that in 1991?
Your answer should be compact. 1.1. What is the ratio of the Value added (constant 2005 US$) of Services in 1989 to that in 1991?
Offer a terse response. 0.96. What is the ratio of the Value added (constant 2005 US$) of Agriculture in 1989 to that in 1991?
Ensure brevity in your answer.  0.96. What is the ratio of the Value added (constant 2005 US$) of Industry in 1989 to that in 1992?
Offer a terse response. 1.1. What is the ratio of the Value added (constant 2005 US$) in Services in 1989 to that in 1992?
Your response must be concise. 0.94. What is the ratio of the Value added (constant 2005 US$) of Agriculture in 1989 to that in 1992?
Make the answer very short. 0.89. What is the ratio of the Value added (constant 2005 US$) of Industry in 1989 to that in 1993?
Provide a succinct answer. 1.04. What is the ratio of the Value added (constant 2005 US$) of Services in 1989 to that in 1993?
Your answer should be very brief. 0.92. What is the ratio of the Value added (constant 2005 US$) in Agriculture in 1989 to that in 1993?
Offer a terse response. 0.87. What is the ratio of the Value added (constant 2005 US$) of Industry in 1989 to that in 1994?
Your answer should be compact. 0.93. What is the ratio of the Value added (constant 2005 US$) of Services in 1989 to that in 1994?
Offer a very short reply. 0.88. What is the ratio of the Value added (constant 2005 US$) in Agriculture in 1989 to that in 1994?
Give a very brief answer. 0.87. What is the ratio of the Value added (constant 2005 US$) of Industry in 1989 to that in 1995?
Your response must be concise. 0.85. What is the ratio of the Value added (constant 2005 US$) of Services in 1989 to that in 1995?
Ensure brevity in your answer.  0.86. What is the ratio of the Value added (constant 2005 US$) in Agriculture in 1989 to that in 1995?
Give a very brief answer. 0.87. What is the ratio of the Value added (constant 2005 US$) of Industry in 1990 to that in 1991?
Offer a very short reply. 1.11. What is the ratio of the Value added (constant 2005 US$) in Services in 1990 to that in 1991?
Offer a terse response. 0.93. What is the ratio of the Value added (constant 2005 US$) in Agriculture in 1990 to that in 1991?
Your answer should be very brief. 0.91. What is the ratio of the Value added (constant 2005 US$) of Industry in 1990 to that in 1992?
Offer a very short reply. 1.11. What is the ratio of the Value added (constant 2005 US$) in Services in 1990 to that in 1992?
Provide a succinct answer. 0.92. What is the ratio of the Value added (constant 2005 US$) of Agriculture in 1990 to that in 1992?
Provide a succinct answer. 0.85. What is the ratio of the Value added (constant 2005 US$) in Industry in 1990 to that in 1993?
Your answer should be very brief. 1.05. What is the ratio of the Value added (constant 2005 US$) of Services in 1990 to that in 1993?
Offer a terse response. 0.9. What is the ratio of the Value added (constant 2005 US$) of Agriculture in 1990 to that in 1993?
Offer a very short reply. 0.83. What is the ratio of the Value added (constant 2005 US$) in Industry in 1990 to that in 1994?
Your response must be concise. 0.94. What is the ratio of the Value added (constant 2005 US$) of Services in 1990 to that in 1994?
Ensure brevity in your answer.  0.86. What is the ratio of the Value added (constant 2005 US$) of Agriculture in 1990 to that in 1994?
Make the answer very short. 0.83. What is the ratio of the Value added (constant 2005 US$) in Industry in 1990 to that in 1995?
Provide a succinct answer. 0.86. What is the ratio of the Value added (constant 2005 US$) in Services in 1990 to that in 1995?
Provide a succinct answer. 0.84. What is the ratio of the Value added (constant 2005 US$) in Agriculture in 1990 to that in 1995?
Your answer should be very brief. 0.82. What is the ratio of the Value added (constant 2005 US$) of Industry in 1991 to that in 1992?
Provide a short and direct response. 1. What is the ratio of the Value added (constant 2005 US$) of Services in 1991 to that in 1992?
Offer a very short reply. 0.98. What is the ratio of the Value added (constant 2005 US$) in Agriculture in 1991 to that in 1992?
Provide a short and direct response. 0.93. What is the ratio of the Value added (constant 2005 US$) of Industry in 1991 to that in 1993?
Your answer should be very brief. 0.94. What is the ratio of the Value added (constant 2005 US$) in Services in 1991 to that in 1993?
Make the answer very short. 0.96. What is the ratio of the Value added (constant 2005 US$) in Agriculture in 1991 to that in 1993?
Make the answer very short. 0.91. What is the ratio of the Value added (constant 2005 US$) in Industry in 1991 to that in 1994?
Provide a short and direct response. 0.85. What is the ratio of the Value added (constant 2005 US$) in Services in 1991 to that in 1994?
Provide a short and direct response. 0.92. What is the ratio of the Value added (constant 2005 US$) in Agriculture in 1991 to that in 1994?
Give a very brief answer. 0.91. What is the ratio of the Value added (constant 2005 US$) in Industry in 1991 to that in 1995?
Your response must be concise. 0.77. What is the ratio of the Value added (constant 2005 US$) in Agriculture in 1991 to that in 1995?
Offer a terse response. 0.91. What is the ratio of the Value added (constant 2005 US$) in Industry in 1992 to that in 1993?
Give a very brief answer. 0.95. What is the ratio of the Value added (constant 2005 US$) in Services in 1992 to that in 1993?
Your response must be concise. 0.98. What is the ratio of the Value added (constant 2005 US$) in Industry in 1992 to that in 1994?
Make the answer very short. 0.85. What is the ratio of the Value added (constant 2005 US$) of Services in 1992 to that in 1994?
Make the answer very short. 0.94. What is the ratio of the Value added (constant 2005 US$) of Agriculture in 1992 to that in 1994?
Ensure brevity in your answer.  0.98. What is the ratio of the Value added (constant 2005 US$) of Industry in 1992 to that in 1995?
Your answer should be compact. 0.77. What is the ratio of the Value added (constant 2005 US$) in Services in 1992 to that in 1995?
Your response must be concise. 0.91. What is the ratio of the Value added (constant 2005 US$) in Agriculture in 1992 to that in 1995?
Provide a short and direct response. 0.97. What is the ratio of the Value added (constant 2005 US$) in Industry in 1993 to that in 1994?
Give a very brief answer. 0.9. What is the ratio of the Value added (constant 2005 US$) in Services in 1993 to that in 1994?
Your response must be concise. 0.96. What is the ratio of the Value added (constant 2005 US$) in Industry in 1993 to that in 1995?
Your answer should be very brief. 0.82. What is the ratio of the Value added (constant 2005 US$) of Services in 1993 to that in 1995?
Offer a terse response. 0.93. What is the ratio of the Value added (constant 2005 US$) of Agriculture in 1993 to that in 1995?
Ensure brevity in your answer.  1. What is the ratio of the Value added (constant 2005 US$) of Industry in 1994 to that in 1995?
Give a very brief answer. 0.91. What is the ratio of the Value added (constant 2005 US$) of Services in 1994 to that in 1995?
Your answer should be compact. 0.98. What is the difference between the highest and the second highest Value added (constant 2005 US$) in Industry?
Give a very brief answer. 3.46e+06. What is the difference between the highest and the second highest Value added (constant 2005 US$) in Services?
Give a very brief answer. 2.38e+06. What is the difference between the highest and the second highest Value added (constant 2005 US$) of Agriculture?
Give a very brief answer. 1.02e+05. What is the difference between the highest and the lowest Value added (constant 2005 US$) in Industry?
Keep it short and to the point. 8.96e+06. What is the difference between the highest and the lowest Value added (constant 2005 US$) in Services?
Your answer should be very brief. 1.53e+07. What is the difference between the highest and the lowest Value added (constant 2005 US$) in Agriculture?
Your answer should be compact. 7.86e+06. 